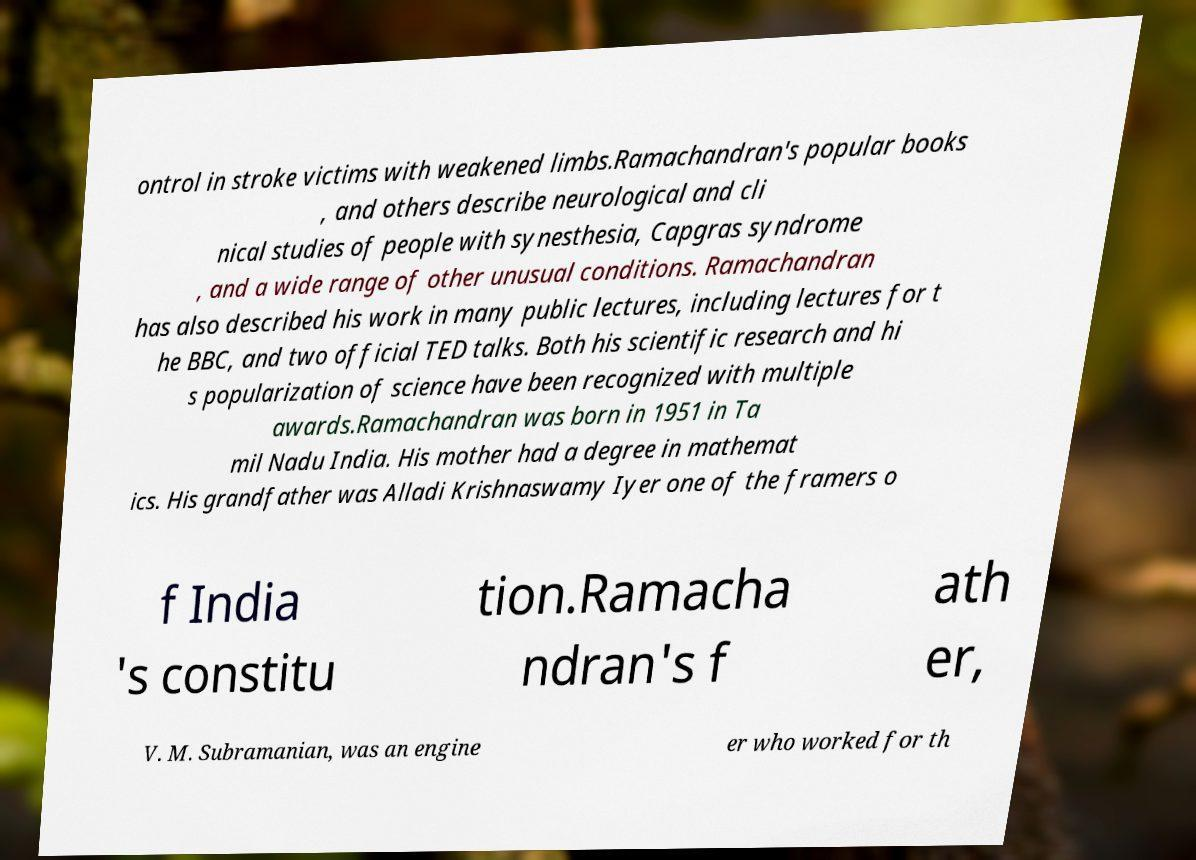Can you accurately transcribe the text from the provided image for me? ontrol in stroke victims with weakened limbs.Ramachandran's popular books , and others describe neurological and cli nical studies of people with synesthesia, Capgras syndrome , and a wide range of other unusual conditions. Ramachandran has also described his work in many public lectures, including lectures for t he BBC, and two official TED talks. Both his scientific research and hi s popularization of science have been recognized with multiple awards.Ramachandran was born in 1951 in Ta mil Nadu India. His mother had a degree in mathemat ics. His grandfather was Alladi Krishnaswamy Iyer one of the framers o f India 's constitu tion.Ramacha ndran's f ath er, V. M. Subramanian, was an engine er who worked for th 